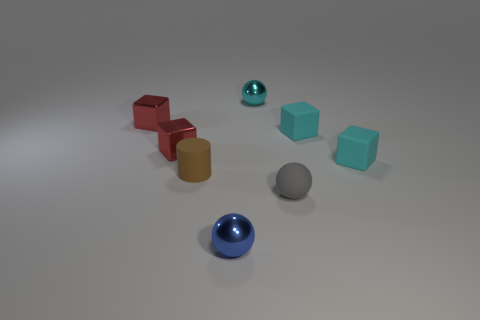How do the textures of the objects compare? The objects seem to have a smooth texture with a soft sheen, especially noticeable on the spheres and the cylinder. The consistent texture across different geometries provides a cohesive look to the arrangement. 